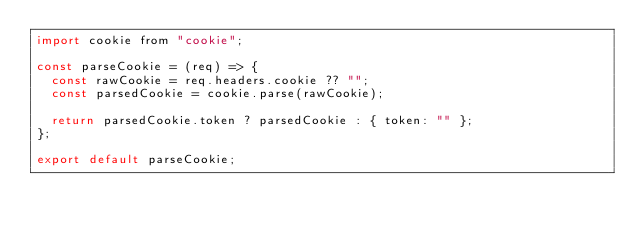<code> <loc_0><loc_0><loc_500><loc_500><_JavaScript_>import cookie from "cookie";

const parseCookie = (req) => {
  const rawCookie = req.headers.cookie ?? "";
  const parsedCookie = cookie.parse(rawCookie);

  return parsedCookie.token ? parsedCookie : { token: "" };
};

export default parseCookie;
</code> 